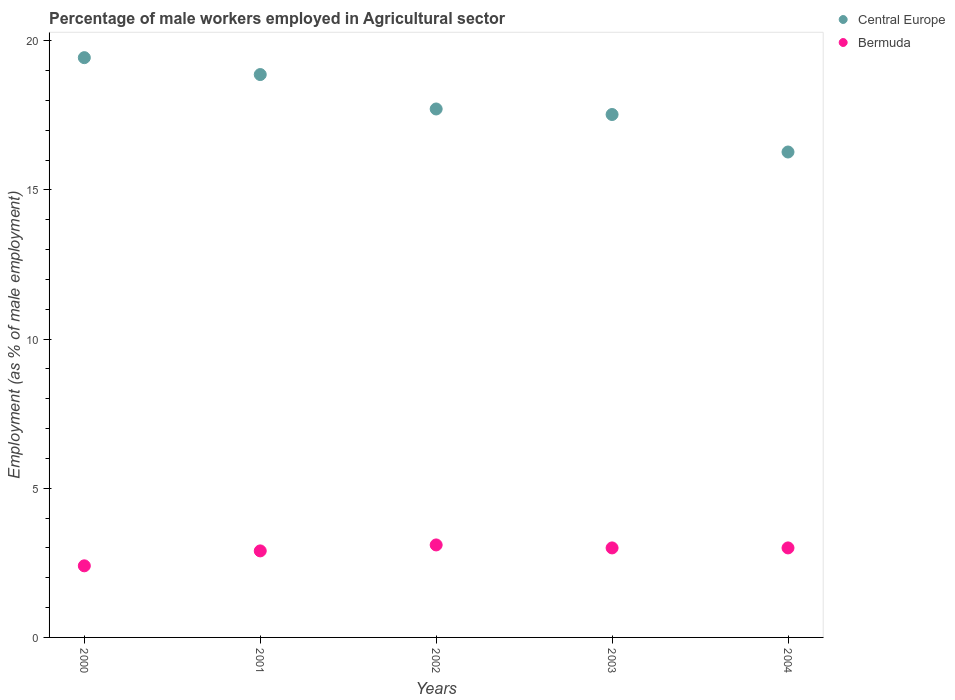How many different coloured dotlines are there?
Give a very brief answer. 2. Is the number of dotlines equal to the number of legend labels?
Offer a very short reply. Yes. What is the percentage of male workers employed in Agricultural sector in Bermuda in 2002?
Provide a short and direct response. 3.1. Across all years, what is the maximum percentage of male workers employed in Agricultural sector in Central Europe?
Make the answer very short. 19.43. Across all years, what is the minimum percentage of male workers employed in Agricultural sector in Central Europe?
Your answer should be compact. 16.27. In which year was the percentage of male workers employed in Agricultural sector in Bermuda maximum?
Make the answer very short. 2002. In which year was the percentage of male workers employed in Agricultural sector in Central Europe minimum?
Ensure brevity in your answer.  2004. What is the total percentage of male workers employed in Agricultural sector in Bermuda in the graph?
Make the answer very short. 14.4. What is the difference between the percentage of male workers employed in Agricultural sector in Central Europe in 2000 and that in 2003?
Your response must be concise. 1.91. What is the difference between the percentage of male workers employed in Agricultural sector in Bermuda in 2001 and the percentage of male workers employed in Agricultural sector in Central Europe in 2000?
Offer a terse response. -16.53. What is the average percentage of male workers employed in Agricultural sector in Bermuda per year?
Keep it short and to the point. 2.88. In the year 2003, what is the difference between the percentage of male workers employed in Agricultural sector in Central Europe and percentage of male workers employed in Agricultural sector in Bermuda?
Keep it short and to the point. 14.53. What is the ratio of the percentage of male workers employed in Agricultural sector in Central Europe in 2000 to that in 2002?
Provide a succinct answer. 1.1. Is the percentage of male workers employed in Agricultural sector in Bermuda in 2000 less than that in 2004?
Keep it short and to the point. Yes. What is the difference between the highest and the second highest percentage of male workers employed in Agricultural sector in Bermuda?
Keep it short and to the point. 0.1. What is the difference between the highest and the lowest percentage of male workers employed in Agricultural sector in Bermuda?
Ensure brevity in your answer.  0.7. Does the percentage of male workers employed in Agricultural sector in Central Europe monotonically increase over the years?
Offer a terse response. No. How many years are there in the graph?
Your answer should be compact. 5. Does the graph contain any zero values?
Your answer should be compact. No. Does the graph contain grids?
Your answer should be very brief. No. Where does the legend appear in the graph?
Your answer should be compact. Top right. What is the title of the graph?
Your answer should be very brief. Percentage of male workers employed in Agricultural sector. Does "West Bank and Gaza" appear as one of the legend labels in the graph?
Provide a short and direct response. No. What is the label or title of the X-axis?
Offer a very short reply. Years. What is the label or title of the Y-axis?
Your response must be concise. Employment (as % of male employment). What is the Employment (as % of male employment) in Central Europe in 2000?
Offer a very short reply. 19.43. What is the Employment (as % of male employment) in Bermuda in 2000?
Keep it short and to the point. 2.4. What is the Employment (as % of male employment) of Central Europe in 2001?
Provide a succinct answer. 18.87. What is the Employment (as % of male employment) in Bermuda in 2001?
Offer a terse response. 2.9. What is the Employment (as % of male employment) of Central Europe in 2002?
Give a very brief answer. 17.71. What is the Employment (as % of male employment) of Bermuda in 2002?
Ensure brevity in your answer.  3.1. What is the Employment (as % of male employment) in Central Europe in 2003?
Your answer should be compact. 17.53. What is the Employment (as % of male employment) in Bermuda in 2003?
Your response must be concise. 3. What is the Employment (as % of male employment) of Central Europe in 2004?
Keep it short and to the point. 16.27. What is the Employment (as % of male employment) of Bermuda in 2004?
Offer a terse response. 3. Across all years, what is the maximum Employment (as % of male employment) of Central Europe?
Keep it short and to the point. 19.43. Across all years, what is the maximum Employment (as % of male employment) in Bermuda?
Provide a short and direct response. 3.1. Across all years, what is the minimum Employment (as % of male employment) of Central Europe?
Keep it short and to the point. 16.27. Across all years, what is the minimum Employment (as % of male employment) in Bermuda?
Your answer should be very brief. 2.4. What is the total Employment (as % of male employment) in Central Europe in the graph?
Ensure brevity in your answer.  89.8. What is the total Employment (as % of male employment) of Bermuda in the graph?
Keep it short and to the point. 14.4. What is the difference between the Employment (as % of male employment) of Central Europe in 2000 and that in 2001?
Provide a short and direct response. 0.57. What is the difference between the Employment (as % of male employment) of Central Europe in 2000 and that in 2002?
Offer a very short reply. 1.72. What is the difference between the Employment (as % of male employment) of Central Europe in 2000 and that in 2003?
Provide a succinct answer. 1.91. What is the difference between the Employment (as % of male employment) in Bermuda in 2000 and that in 2003?
Your response must be concise. -0.6. What is the difference between the Employment (as % of male employment) in Central Europe in 2000 and that in 2004?
Keep it short and to the point. 3.16. What is the difference between the Employment (as % of male employment) of Central Europe in 2001 and that in 2002?
Offer a terse response. 1.15. What is the difference between the Employment (as % of male employment) of Central Europe in 2001 and that in 2003?
Provide a short and direct response. 1.34. What is the difference between the Employment (as % of male employment) in Bermuda in 2001 and that in 2003?
Keep it short and to the point. -0.1. What is the difference between the Employment (as % of male employment) of Central Europe in 2001 and that in 2004?
Make the answer very short. 2.6. What is the difference between the Employment (as % of male employment) of Bermuda in 2001 and that in 2004?
Keep it short and to the point. -0.1. What is the difference between the Employment (as % of male employment) in Central Europe in 2002 and that in 2003?
Your answer should be compact. 0.19. What is the difference between the Employment (as % of male employment) in Central Europe in 2002 and that in 2004?
Provide a succinct answer. 1.44. What is the difference between the Employment (as % of male employment) of Bermuda in 2002 and that in 2004?
Provide a short and direct response. 0.1. What is the difference between the Employment (as % of male employment) in Central Europe in 2003 and that in 2004?
Provide a short and direct response. 1.26. What is the difference between the Employment (as % of male employment) in Central Europe in 2000 and the Employment (as % of male employment) in Bermuda in 2001?
Give a very brief answer. 16.53. What is the difference between the Employment (as % of male employment) in Central Europe in 2000 and the Employment (as % of male employment) in Bermuda in 2002?
Your answer should be compact. 16.33. What is the difference between the Employment (as % of male employment) of Central Europe in 2000 and the Employment (as % of male employment) of Bermuda in 2003?
Make the answer very short. 16.43. What is the difference between the Employment (as % of male employment) in Central Europe in 2000 and the Employment (as % of male employment) in Bermuda in 2004?
Offer a very short reply. 16.43. What is the difference between the Employment (as % of male employment) in Central Europe in 2001 and the Employment (as % of male employment) in Bermuda in 2002?
Your answer should be compact. 15.77. What is the difference between the Employment (as % of male employment) in Central Europe in 2001 and the Employment (as % of male employment) in Bermuda in 2003?
Make the answer very short. 15.87. What is the difference between the Employment (as % of male employment) of Central Europe in 2001 and the Employment (as % of male employment) of Bermuda in 2004?
Your answer should be very brief. 15.87. What is the difference between the Employment (as % of male employment) of Central Europe in 2002 and the Employment (as % of male employment) of Bermuda in 2003?
Offer a very short reply. 14.71. What is the difference between the Employment (as % of male employment) of Central Europe in 2002 and the Employment (as % of male employment) of Bermuda in 2004?
Offer a terse response. 14.71. What is the difference between the Employment (as % of male employment) in Central Europe in 2003 and the Employment (as % of male employment) in Bermuda in 2004?
Offer a very short reply. 14.53. What is the average Employment (as % of male employment) of Central Europe per year?
Offer a terse response. 17.96. What is the average Employment (as % of male employment) in Bermuda per year?
Provide a short and direct response. 2.88. In the year 2000, what is the difference between the Employment (as % of male employment) in Central Europe and Employment (as % of male employment) in Bermuda?
Provide a short and direct response. 17.03. In the year 2001, what is the difference between the Employment (as % of male employment) in Central Europe and Employment (as % of male employment) in Bermuda?
Ensure brevity in your answer.  15.97. In the year 2002, what is the difference between the Employment (as % of male employment) of Central Europe and Employment (as % of male employment) of Bermuda?
Your answer should be very brief. 14.61. In the year 2003, what is the difference between the Employment (as % of male employment) of Central Europe and Employment (as % of male employment) of Bermuda?
Make the answer very short. 14.53. In the year 2004, what is the difference between the Employment (as % of male employment) in Central Europe and Employment (as % of male employment) in Bermuda?
Keep it short and to the point. 13.27. What is the ratio of the Employment (as % of male employment) in Bermuda in 2000 to that in 2001?
Provide a succinct answer. 0.83. What is the ratio of the Employment (as % of male employment) of Central Europe in 2000 to that in 2002?
Offer a very short reply. 1.1. What is the ratio of the Employment (as % of male employment) of Bermuda in 2000 to that in 2002?
Your answer should be compact. 0.77. What is the ratio of the Employment (as % of male employment) in Central Europe in 2000 to that in 2003?
Your response must be concise. 1.11. What is the ratio of the Employment (as % of male employment) in Central Europe in 2000 to that in 2004?
Give a very brief answer. 1.19. What is the ratio of the Employment (as % of male employment) of Central Europe in 2001 to that in 2002?
Offer a very short reply. 1.07. What is the ratio of the Employment (as % of male employment) of Bermuda in 2001 to that in 2002?
Provide a short and direct response. 0.94. What is the ratio of the Employment (as % of male employment) in Central Europe in 2001 to that in 2003?
Your response must be concise. 1.08. What is the ratio of the Employment (as % of male employment) in Bermuda in 2001 to that in 2003?
Make the answer very short. 0.97. What is the ratio of the Employment (as % of male employment) of Central Europe in 2001 to that in 2004?
Keep it short and to the point. 1.16. What is the ratio of the Employment (as % of male employment) in Bermuda in 2001 to that in 2004?
Provide a succinct answer. 0.97. What is the ratio of the Employment (as % of male employment) in Central Europe in 2002 to that in 2003?
Provide a succinct answer. 1.01. What is the ratio of the Employment (as % of male employment) of Central Europe in 2002 to that in 2004?
Ensure brevity in your answer.  1.09. What is the ratio of the Employment (as % of male employment) of Central Europe in 2003 to that in 2004?
Ensure brevity in your answer.  1.08. What is the difference between the highest and the second highest Employment (as % of male employment) of Central Europe?
Your answer should be compact. 0.57. What is the difference between the highest and the lowest Employment (as % of male employment) in Central Europe?
Your answer should be very brief. 3.16. What is the difference between the highest and the lowest Employment (as % of male employment) in Bermuda?
Provide a succinct answer. 0.7. 